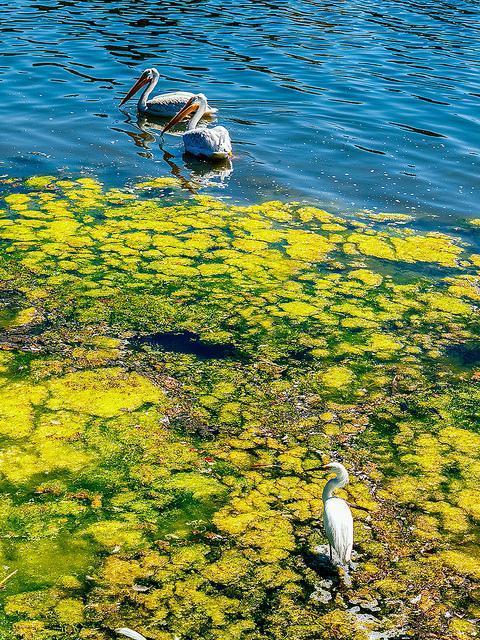How many birds are in the picture?
Give a very brief answer. 3. How many people are shown?
Give a very brief answer. 0. 